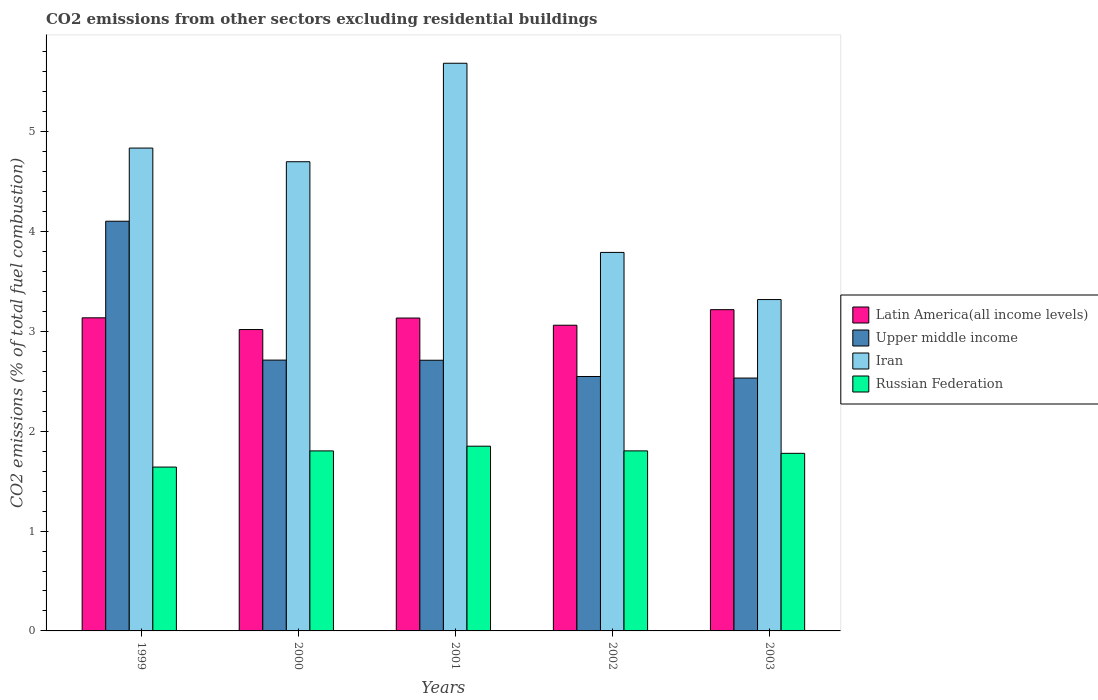How many different coloured bars are there?
Your answer should be compact. 4. Are the number of bars per tick equal to the number of legend labels?
Ensure brevity in your answer.  Yes. How many bars are there on the 5th tick from the left?
Ensure brevity in your answer.  4. What is the label of the 1st group of bars from the left?
Give a very brief answer. 1999. In how many cases, is the number of bars for a given year not equal to the number of legend labels?
Provide a short and direct response. 0. What is the total CO2 emitted in Russian Federation in 2001?
Offer a terse response. 1.85. Across all years, what is the maximum total CO2 emitted in Russian Federation?
Offer a terse response. 1.85. Across all years, what is the minimum total CO2 emitted in Iran?
Provide a short and direct response. 3.32. In which year was the total CO2 emitted in Iran maximum?
Offer a terse response. 2001. In which year was the total CO2 emitted in Iran minimum?
Give a very brief answer. 2003. What is the total total CO2 emitted in Upper middle income in the graph?
Provide a succinct answer. 14.61. What is the difference between the total CO2 emitted in Upper middle income in 2001 and that in 2002?
Ensure brevity in your answer.  0.16. What is the difference between the total CO2 emitted in Upper middle income in 2000 and the total CO2 emitted in Iran in 2001?
Provide a succinct answer. -2.97. What is the average total CO2 emitted in Iran per year?
Your answer should be very brief. 4.47. In the year 2002, what is the difference between the total CO2 emitted in Russian Federation and total CO2 emitted in Latin America(all income levels)?
Ensure brevity in your answer.  -1.26. What is the ratio of the total CO2 emitted in Upper middle income in 2000 to that in 2003?
Offer a very short reply. 1.07. Is the total CO2 emitted in Iran in 1999 less than that in 2003?
Your answer should be very brief. No. What is the difference between the highest and the second highest total CO2 emitted in Latin America(all income levels)?
Keep it short and to the point. 0.08. What is the difference between the highest and the lowest total CO2 emitted in Iran?
Give a very brief answer. 2.37. Is the sum of the total CO2 emitted in Latin America(all income levels) in 2001 and 2002 greater than the maximum total CO2 emitted in Upper middle income across all years?
Offer a very short reply. Yes. Is it the case that in every year, the sum of the total CO2 emitted in Iran and total CO2 emitted in Latin America(all income levels) is greater than the sum of total CO2 emitted in Russian Federation and total CO2 emitted in Upper middle income?
Give a very brief answer. Yes. What does the 1st bar from the left in 2002 represents?
Ensure brevity in your answer.  Latin America(all income levels). What does the 3rd bar from the right in 1999 represents?
Your answer should be compact. Upper middle income. What is the difference between two consecutive major ticks on the Y-axis?
Give a very brief answer. 1. Are the values on the major ticks of Y-axis written in scientific E-notation?
Ensure brevity in your answer.  No. What is the title of the graph?
Provide a short and direct response. CO2 emissions from other sectors excluding residential buildings. Does "Egypt, Arab Rep." appear as one of the legend labels in the graph?
Your response must be concise. No. What is the label or title of the Y-axis?
Provide a short and direct response. CO2 emissions (% of total fuel combustion). What is the CO2 emissions (% of total fuel combustion) of Latin America(all income levels) in 1999?
Your answer should be compact. 3.14. What is the CO2 emissions (% of total fuel combustion) in Upper middle income in 1999?
Your answer should be very brief. 4.1. What is the CO2 emissions (% of total fuel combustion) in Iran in 1999?
Your response must be concise. 4.84. What is the CO2 emissions (% of total fuel combustion) of Russian Federation in 1999?
Give a very brief answer. 1.64. What is the CO2 emissions (% of total fuel combustion) in Latin America(all income levels) in 2000?
Your response must be concise. 3.02. What is the CO2 emissions (% of total fuel combustion) of Upper middle income in 2000?
Your answer should be very brief. 2.71. What is the CO2 emissions (% of total fuel combustion) of Iran in 2000?
Offer a terse response. 4.7. What is the CO2 emissions (% of total fuel combustion) in Russian Federation in 2000?
Provide a short and direct response. 1.8. What is the CO2 emissions (% of total fuel combustion) of Latin America(all income levels) in 2001?
Give a very brief answer. 3.13. What is the CO2 emissions (% of total fuel combustion) of Upper middle income in 2001?
Make the answer very short. 2.71. What is the CO2 emissions (% of total fuel combustion) of Iran in 2001?
Provide a succinct answer. 5.69. What is the CO2 emissions (% of total fuel combustion) in Russian Federation in 2001?
Your response must be concise. 1.85. What is the CO2 emissions (% of total fuel combustion) in Latin America(all income levels) in 2002?
Your answer should be very brief. 3.06. What is the CO2 emissions (% of total fuel combustion) in Upper middle income in 2002?
Provide a succinct answer. 2.55. What is the CO2 emissions (% of total fuel combustion) in Iran in 2002?
Offer a terse response. 3.79. What is the CO2 emissions (% of total fuel combustion) of Russian Federation in 2002?
Offer a very short reply. 1.8. What is the CO2 emissions (% of total fuel combustion) of Latin America(all income levels) in 2003?
Make the answer very short. 3.22. What is the CO2 emissions (% of total fuel combustion) in Upper middle income in 2003?
Give a very brief answer. 2.53. What is the CO2 emissions (% of total fuel combustion) of Iran in 2003?
Give a very brief answer. 3.32. What is the CO2 emissions (% of total fuel combustion) in Russian Federation in 2003?
Your response must be concise. 1.78. Across all years, what is the maximum CO2 emissions (% of total fuel combustion) of Latin America(all income levels)?
Ensure brevity in your answer.  3.22. Across all years, what is the maximum CO2 emissions (% of total fuel combustion) of Upper middle income?
Provide a short and direct response. 4.1. Across all years, what is the maximum CO2 emissions (% of total fuel combustion) of Iran?
Your answer should be compact. 5.69. Across all years, what is the maximum CO2 emissions (% of total fuel combustion) of Russian Federation?
Provide a succinct answer. 1.85. Across all years, what is the minimum CO2 emissions (% of total fuel combustion) of Latin America(all income levels)?
Offer a very short reply. 3.02. Across all years, what is the minimum CO2 emissions (% of total fuel combustion) in Upper middle income?
Offer a terse response. 2.53. Across all years, what is the minimum CO2 emissions (% of total fuel combustion) in Iran?
Provide a succinct answer. 3.32. Across all years, what is the minimum CO2 emissions (% of total fuel combustion) in Russian Federation?
Offer a very short reply. 1.64. What is the total CO2 emissions (% of total fuel combustion) in Latin America(all income levels) in the graph?
Provide a short and direct response. 15.57. What is the total CO2 emissions (% of total fuel combustion) in Upper middle income in the graph?
Provide a succinct answer. 14.61. What is the total CO2 emissions (% of total fuel combustion) in Iran in the graph?
Give a very brief answer. 22.33. What is the total CO2 emissions (% of total fuel combustion) in Russian Federation in the graph?
Provide a succinct answer. 8.88. What is the difference between the CO2 emissions (% of total fuel combustion) of Latin America(all income levels) in 1999 and that in 2000?
Your response must be concise. 0.12. What is the difference between the CO2 emissions (% of total fuel combustion) in Upper middle income in 1999 and that in 2000?
Make the answer very short. 1.39. What is the difference between the CO2 emissions (% of total fuel combustion) in Iran in 1999 and that in 2000?
Give a very brief answer. 0.14. What is the difference between the CO2 emissions (% of total fuel combustion) of Russian Federation in 1999 and that in 2000?
Your answer should be compact. -0.16. What is the difference between the CO2 emissions (% of total fuel combustion) of Latin America(all income levels) in 1999 and that in 2001?
Offer a very short reply. 0. What is the difference between the CO2 emissions (% of total fuel combustion) of Upper middle income in 1999 and that in 2001?
Your response must be concise. 1.39. What is the difference between the CO2 emissions (% of total fuel combustion) of Iran in 1999 and that in 2001?
Ensure brevity in your answer.  -0.85. What is the difference between the CO2 emissions (% of total fuel combustion) of Russian Federation in 1999 and that in 2001?
Give a very brief answer. -0.21. What is the difference between the CO2 emissions (% of total fuel combustion) in Latin America(all income levels) in 1999 and that in 2002?
Provide a succinct answer. 0.07. What is the difference between the CO2 emissions (% of total fuel combustion) of Upper middle income in 1999 and that in 2002?
Keep it short and to the point. 1.56. What is the difference between the CO2 emissions (% of total fuel combustion) of Iran in 1999 and that in 2002?
Make the answer very short. 1.05. What is the difference between the CO2 emissions (% of total fuel combustion) in Russian Federation in 1999 and that in 2002?
Provide a short and direct response. -0.16. What is the difference between the CO2 emissions (% of total fuel combustion) in Latin America(all income levels) in 1999 and that in 2003?
Make the answer very short. -0.08. What is the difference between the CO2 emissions (% of total fuel combustion) in Upper middle income in 1999 and that in 2003?
Offer a terse response. 1.57. What is the difference between the CO2 emissions (% of total fuel combustion) in Iran in 1999 and that in 2003?
Offer a very short reply. 1.52. What is the difference between the CO2 emissions (% of total fuel combustion) in Russian Federation in 1999 and that in 2003?
Make the answer very short. -0.14. What is the difference between the CO2 emissions (% of total fuel combustion) in Latin America(all income levels) in 2000 and that in 2001?
Your answer should be very brief. -0.12. What is the difference between the CO2 emissions (% of total fuel combustion) in Upper middle income in 2000 and that in 2001?
Keep it short and to the point. 0. What is the difference between the CO2 emissions (% of total fuel combustion) in Iran in 2000 and that in 2001?
Keep it short and to the point. -0.99. What is the difference between the CO2 emissions (% of total fuel combustion) of Russian Federation in 2000 and that in 2001?
Offer a very short reply. -0.05. What is the difference between the CO2 emissions (% of total fuel combustion) of Latin America(all income levels) in 2000 and that in 2002?
Give a very brief answer. -0.04. What is the difference between the CO2 emissions (% of total fuel combustion) in Upper middle income in 2000 and that in 2002?
Your response must be concise. 0.16. What is the difference between the CO2 emissions (% of total fuel combustion) in Iran in 2000 and that in 2002?
Keep it short and to the point. 0.91. What is the difference between the CO2 emissions (% of total fuel combustion) of Russian Federation in 2000 and that in 2002?
Make the answer very short. -0. What is the difference between the CO2 emissions (% of total fuel combustion) in Latin America(all income levels) in 2000 and that in 2003?
Offer a terse response. -0.2. What is the difference between the CO2 emissions (% of total fuel combustion) in Upper middle income in 2000 and that in 2003?
Make the answer very short. 0.18. What is the difference between the CO2 emissions (% of total fuel combustion) of Iran in 2000 and that in 2003?
Offer a very short reply. 1.38. What is the difference between the CO2 emissions (% of total fuel combustion) in Russian Federation in 2000 and that in 2003?
Offer a terse response. 0.02. What is the difference between the CO2 emissions (% of total fuel combustion) of Latin America(all income levels) in 2001 and that in 2002?
Give a very brief answer. 0.07. What is the difference between the CO2 emissions (% of total fuel combustion) in Upper middle income in 2001 and that in 2002?
Your answer should be compact. 0.16. What is the difference between the CO2 emissions (% of total fuel combustion) in Iran in 2001 and that in 2002?
Give a very brief answer. 1.89. What is the difference between the CO2 emissions (% of total fuel combustion) of Russian Federation in 2001 and that in 2002?
Your response must be concise. 0.05. What is the difference between the CO2 emissions (% of total fuel combustion) of Latin America(all income levels) in 2001 and that in 2003?
Your response must be concise. -0.08. What is the difference between the CO2 emissions (% of total fuel combustion) in Upper middle income in 2001 and that in 2003?
Give a very brief answer. 0.18. What is the difference between the CO2 emissions (% of total fuel combustion) in Iran in 2001 and that in 2003?
Provide a succinct answer. 2.37. What is the difference between the CO2 emissions (% of total fuel combustion) in Russian Federation in 2001 and that in 2003?
Make the answer very short. 0.07. What is the difference between the CO2 emissions (% of total fuel combustion) of Latin America(all income levels) in 2002 and that in 2003?
Offer a very short reply. -0.16. What is the difference between the CO2 emissions (% of total fuel combustion) in Upper middle income in 2002 and that in 2003?
Offer a terse response. 0.02. What is the difference between the CO2 emissions (% of total fuel combustion) in Iran in 2002 and that in 2003?
Your answer should be compact. 0.47. What is the difference between the CO2 emissions (% of total fuel combustion) in Russian Federation in 2002 and that in 2003?
Offer a very short reply. 0.02. What is the difference between the CO2 emissions (% of total fuel combustion) in Latin America(all income levels) in 1999 and the CO2 emissions (% of total fuel combustion) in Upper middle income in 2000?
Offer a very short reply. 0.42. What is the difference between the CO2 emissions (% of total fuel combustion) of Latin America(all income levels) in 1999 and the CO2 emissions (% of total fuel combustion) of Iran in 2000?
Offer a terse response. -1.56. What is the difference between the CO2 emissions (% of total fuel combustion) of Latin America(all income levels) in 1999 and the CO2 emissions (% of total fuel combustion) of Russian Federation in 2000?
Offer a very short reply. 1.33. What is the difference between the CO2 emissions (% of total fuel combustion) of Upper middle income in 1999 and the CO2 emissions (% of total fuel combustion) of Iran in 2000?
Give a very brief answer. -0.6. What is the difference between the CO2 emissions (% of total fuel combustion) of Upper middle income in 1999 and the CO2 emissions (% of total fuel combustion) of Russian Federation in 2000?
Ensure brevity in your answer.  2.3. What is the difference between the CO2 emissions (% of total fuel combustion) in Iran in 1999 and the CO2 emissions (% of total fuel combustion) in Russian Federation in 2000?
Ensure brevity in your answer.  3.03. What is the difference between the CO2 emissions (% of total fuel combustion) of Latin America(all income levels) in 1999 and the CO2 emissions (% of total fuel combustion) of Upper middle income in 2001?
Provide a short and direct response. 0.42. What is the difference between the CO2 emissions (% of total fuel combustion) of Latin America(all income levels) in 1999 and the CO2 emissions (% of total fuel combustion) of Iran in 2001?
Make the answer very short. -2.55. What is the difference between the CO2 emissions (% of total fuel combustion) of Latin America(all income levels) in 1999 and the CO2 emissions (% of total fuel combustion) of Russian Federation in 2001?
Your answer should be compact. 1.29. What is the difference between the CO2 emissions (% of total fuel combustion) in Upper middle income in 1999 and the CO2 emissions (% of total fuel combustion) in Iran in 2001?
Ensure brevity in your answer.  -1.58. What is the difference between the CO2 emissions (% of total fuel combustion) of Upper middle income in 1999 and the CO2 emissions (% of total fuel combustion) of Russian Federation in 2001?
Ensure brevity in your answer.  2.25. What is the difference between the CO2 emissions (% of total fuel combustion) in Iran in 1999 and the CO2 emissions (% of total fuel combustion) in Russian Federation in 2001?
Ensure brevity in your answer.  2.99. What is the difference between the CO2 emissions (% of total fuel combustion) in Latin America(all income levels) in 1999 and the CO2 emissions (% of total fuel combustion) in Upper middle income in 2002?
Ensure brevity in your answer.  0.59. What is the difference between the CO2 emissions (% of total fuel combustion) in Latin America(all income levels) in 1999 and the CO2 emissions (% of total fuel combustion) in Iran in 2002?
Your answer should be very brief. -0.66. What is the difference between the CO2 emissions (% of total fuel combustion) of Latin America(all income levels) in 1999 and the CO2 emissions (% of total fuel combustion) of Russian Federation in 2002?
Ensure brevity in your answer.  1.33. What is the difference between the CO2 emissions (% of total fuel combustion) of Upper middle income in 1999 and the CO2 emissions (% of total fuel combustion) of Iran in 2002?
Provide a succinct answer. 0.31. What is the difference between the CO2 emissions (% of total fuel combustion) of Upper middle income in 1999 and the CO2 emissions (% of total fuel combustion) of Russian Federation in 2002?
Offer a very short reply. 2.3. What is the difference between the CO2 emissions (% of total fuel combustion) in Iran in 1999 and the CO2 emissions (% of total fuel combustion) in Russian Federation in 2002?
Give a very brief answer. 3.03. What is the difference between the CO2 emissions (% of total fuel combustion) in Latin America(all income levels) in 1999 and the CO2 emissions (% of total fuel combustion) in Upper middle income in 2003?
Your response must be concise. 0.6. What is the difference between the CO2 emissions (% of total fuel combustion) in Latin America(all income levels) in 1999 and the CO2 emissions (% of total fuel combustion) in Iran in 2003?
Offer a terse response. -0.18. What is the difference between the CO2 emissions (% of total fuel combustion) in Latin America(all income levels) in 1999 and the CO2 emissions (% of total fuel combustion) in Russian Federation in 2003?
Give a very brief answer. 1.36. What is the difference between the CO2 emissions (% of total fuel combustion) in Upper middle income in 1999 and the CO2 emissions (% of total fuel combustion) in Iran in 2003?
Ensure brevity in your answer.  0.78. What is the difference between the CO2 emissions (% of total fuel combustion) of Upper middle income in 1999 and the CO2 emissions (% of total fuel combustion) of Russian Federation in 2003?
Make the answer very short. 2.33. What is the difference between the CO2 emissions (% of total fuel combustion) of Iran in 1999 and the CO2 emissions (% of total fuel combustion) of Russian Federation in 2003?
Make the answer very short. 3.06. What is the difference between the CO2 emissions (% of total fuel combustion) of Latin America(all income levels) in 2000 and the CO2 emissions (% of total fuel combustion) of Upper middle income in 2001?
Offer a terse response. 0.31. What is the difference between the CO2 emissions (% of total fuel combustion) of Latin America(all income levels) in 2000 and the CO2 emissions (% of total fuel combustion) of Iran in 2001?
Provide a short and direct response. -2.67. What is the difference between the CO2 emissions (% of total fuel combustion) of Latin America(all income levels) in 2000 and the CO2 emissions (% of total fuel combustion) of Russian Federation in 2001?
Provide a short and direct response. 1.17. What is the difference between the CO2 emissions (% of total fuel combustion) of Upper middle income in 2000 and the CO2 emissions (% of total fuel combustion) of Iran in 2001?
Ensure brevity in your answer.  -2.97. What is the difference between the CO2 emissions (% of total fuel combustion) of Upper middle income in 2000 and the CO2 emissions (% of total fuel combustion) of Russian Federation in 2001?
Your answer should be very brief. 0.86. What is the difference between the CO2 emissions (% of total fuel combustion) of Iran in 2000 and the CO2 emissions (% of total fuel combustion) of Russian Federation in 2001?
Your response must be concise. 2.85. What is the difference between the CO2 emissions (% of total fuel combustion) in Latin America(all income levels) in 2000 and the CO2 emissions (% of total fuel combustion) in Upper middle income in 2002?
Your answer should be compact. 0.47. What is the difference between the CO2 emissions (% of total fuel combustion) of Latin America(all income levels) in 2000 and the CO2 emissions (% of total fuel combustion) of Iran in 2002?
Your answer should be compact. -0.77. What is the difference between the CO2 emissions (% of total fuel combustion) in Latin America(all income levels) in 2000 and the CO2 emissions (% of total fuel combustion) in Russian Federation in 2002?
Provide a short and direct response. 1.22. What is the difference between the CO2 emissions (% of total fuel combustion) of Upper middle income in 2000 and the CO2 emissions (% of total fuel combustion) of Iran in 2002?
Your answer should be very brief. -1.08. What is the difference between the CO2 emissions (% of total fuel combustion) in Upper middle income in 2000 and the CO2 emissions (% of total fuel combustion) in Russian Federation in 2002?
Provide a short and direct response. 0.91. What is the difference between the CO2 emissions (% of total fuel combustion) in Iran in 2000 and the CO2 emissions (% of total fuel combustion) in Russian Federation in 2002?
Provide a succinct answer. 2.9. What is the difference between the CO2 emissions (% of total fuel combustion) of Latin America(all income levels) in 2000 and the CO2 emissions (% of total fuel combustion) of Upper middle income in 2003?
Make the answer very short. 0.49. What is the difference between the CO2 emissions (% of total fuel combustion) of Latin America(all income levels) in 2000 and the CO2 emissions (% of total fuel combustion) of Iran in 2003?
Offer a terse response. -0.3. What is the difference between the CO2 emissions (% of total fuel combustion) of Latin America(all income levels) in 2000 and the CO2 emissions (% of total fuel combustion) of Russian Federation in 2003?
Give a very brief answer. 1.24. What is the difference between the CO2 emissions (% of total fuel combustion) in Upper middle income in 2000 and the CO2 emissions (% of total fuel combustion) in Iran in 2003?
Give a very brief answer. -0.61. What is the difference between the CO2 emissions (% of total fuel combustion) in Upper middle income in 2000 and the CO2 emissions (% of total fuel combustion) in Russian Federation in 2003?
Give a very brief answer. 0.93. What is the difference between the CO2 emissions (% of total fuel combustion) in Iran in 2000 and the CO2 emissions (% of total fuel combustion) in Russian Federation in 2003?
Offer a very short reply. 2.92. What is the difference between the CO2 emissions (% of total fuel combustion) of Latin America(all income levels) in 2001 and the CO2 emissions (% of total fuel combustion) of Upper middle income in 2002?
Your answer should be compact. 0.59. What is the difference between the CO2 emissions (% of total fuel combustion) of Latin America(all income levels) in 2001 and the CO2 emissions (% of total fuel combustion) of Iran in 2002?
Give a very brief answer. -0.66. What is the difference between the CO2 emissions (% of total fuel combustion) of Latin America(all income levels) in 2001 and the CO2 emissions (% of total fuel combustion) of Russian Federation in 2002?
Keep it short and to the point. 1.33. What is the difference between the CO2 emissions (% of total fuel combustion) in Upper middle income in 2001 and the CO2 emissions (% of total fuel combustion) in Iran in 2002?
Offer a terse response. -1.08. What is the difference between the CO2 emissions (% of total fuel combustion) in Upper middle income in 2001 and the CO2 emissions (% of total fuel combustion) in Russian Federation in 2002?
Your answer should be compact. 0.91. What is the difference between the CO2 emissions (% of total fuel combustion) of Iran in 2001 and the CO2 emissions (% of total fuel combustion) of Russian Federation in 2002?
Provide a short and direct response. 3.88. What is the difference between the CO2 emissions (% of total fuel combustion) in Latin America(all income levels) in 2001 and the CO2 emissions (% of total fuel combustion) in Upper middle income in 2003?
Offer a terse response. 0.6. What is the difference between the CO2 emissions (% of total fuel combustion) in Latin America(all income levels) in 2001 and the CO2 emissions (% of total fuel combustion) in Iran in 2003?
Keep it short and to the point. -0.18. What is the difference between the CO2 emissions (% of total fuel combustion) in Latin America(all income levels) in 2001 and the CO2 emissions (% of total fuel combustion) in Russian Federation in 2003?
Offer a very short reply. 1.36. What is the difference between the CO2 emissions (% of total fuel combustion) in Upper middle income in 2001 and the CO2 emissions (% of total fuel combustion) in Iran in 2003?
Offer a terse response. -0.61. What is the difference between the CO2 emissions (% of total fuel combustion) of Upper middle income in 2001 and the CO2 emissions (% of total fuel combustion) of Russian Federation in 2003?
Provide a succinct answer. 0.93. What is the difference between the CO2 emissions (% of total fuel combustion) of Iran in 2001 and the CO2 emissions (% of total fuel combustion) of Russian Federation in 2003?
Keep it short and to the point. 3.91. What is the difference between the CO2 emissions (% of total fuel combustion) in Latin America(all income levels) in 2002 and the CO2 emissions (% of total fuel combustion) in Upper middle income in 2003?
Your answer should be compact. 0.53. What is the difference between the CO2 emissions (% of total fuel combustion) in Latin America(all income levels) in 2002 and the CO2 emissions (% of total fuel combustion) in Iran in 2003?
Make the answer very short. -0.26. What is the difference between the CO2 emissions (% of total fuel combustion) of Latin America(all income levels) in 2002 and the CO2 emissions (% of total fuel combustion) of Russian Federation in 2003?
Your response must be concise. 1.28. What is the difference between the CO2 emissions (% of total fuel combustion) of Upper middle income in 2002 and the CO2 emissions (% of total fuel combustion) of Iran in 2003?
Make the answer very short. -0.77. What is the difference between the CO2 emissions (% of total fuel combustion) of Upper middle income in 2002 and the CO2 emissions (% of total fuel combustion) of Russian Federation in 2003?
Give a very brief answer. 0.77. What is the difference between the CO2 emissions (% of total fuel combustion) of Iran in 2002 and the CO2 emissions (% of total fuel combustion) of Russian Federation in 2003?
Make the answer very short. 2.01. What is the average CO2 emissions (% of total fuel combustion) in Latin America(all income levels) per year?
Your answer should be very brief. 3.11. What is the average CO2 emissions (% of total fuel combustion) of Upper middle income per year?
Your answer should be very brief. 2.92. What is the average CO2 emissions (% of total fuel combustion) in Iran per year?
Provide a succinct answer. 4.47. What is the average CO2 emissions (% of total fuel combustion) of Russian Federation per year?
Your response must be concise. 1.78. In the year 1999, what is the difference between the CO2 emissions (% of total fuel combustion) in Latin America(all income levels) and CO2 emissions (% of total fuel combustion) in Upper middle income?
Keep it short and to the point. -0.97. In the year 1999, what is the difference between the CO2 emissions (% of total fuel combustion) in Latin America(all income levels) and CO2 emissions (% of total fuel combustion) in Iran?
Give a very brief answer. -1.7. In the year 1999, what is the difference between the CO2 emissions (% of total fuel combustion) of Latin America(all income levels) and CO2 emissions (% of total fuel combustion) of Russian Federation?
Make the answer very short. 1.5. In the year 1999, what is the difference between the CO2 emissions (% of total fuel combustion) in Upper middle income and CO2 emissions (% of total fuel combustion) in Iran?
Your answer should be very brief. -0.73. In the year 1999, what is the difference between the CO2 emissions (% of total fuel combustion) in Upper middle income and CO2 emissions (% of total fuel combustion) in Russian Federation?
Make the answer very short. 2.46. In the year 1999, what is the difference between the CO2 emissions (% of total fuel combustion) in Iran and CO2 emissions (% of total fuel combustion) in Russian Federation?
Provide a succinct answer. 3.2. In the year 2000, what is the difference between the CO2 emissions (% of total fuel combustion) of Latin America(all income levels) and CO2 emissions (% of total fuel combustion) of Upper middle income?
Keep it short and to the point. 0.31. In the year 2000, what is the difference between the CO2 emissions (% of total fuel combustion) of Latin America(all income levels) and CO2 emissions (% of total fuel combustion) of Iran?
Your response must be concise. -1.68. In the year 2000, what is the difference between the CO2 emissions (% of total fuel combustion) in Latin America(all income levels) and CO2 emissions (% of total fuel combustion) in Russian Federation?
Keep it short and to the point. 1.22. In the year 2000, what is the difference between the CO2 emissions (% of total fuel combustion) in Upper middle income and CO2 emissions (% of total fuel combustion) in Iran?
Give a very brief answer. -1.99. In the year 2000, what is the difference between the CO2 emissions (% of total fuel combustion) in Upper middle income and CO2 emissions (% of total fuel combustion) in Russian Federation?
Give a very brief answer. 0.91. In the year 2000, what is the difference between the CO2 emissions (% of total fuel combustion) in Iran and CO2 emissions (% of total fuel combustion) in Russian Federation?
Keep it short and to the point. 2.9. In the year 2001, what is the difference between the CO2 emissions (% of total fuel combustion) of Latin America(all income levels) and CO2 emissions (% of total fuel combustion) of Upper middle income?
Offer a terse response. 0.42. In the year 2001, what is the difference between the CO2 emissions (% of total fuel combustion) in Latin America(all income levels) and CO2 emissions (% of total fuel combustion) in Iran?
Make the answer very short. -2.55. In the year 2001, what is the difference between the CO2 emissions (% of total fuel combustion) of Latin America(all income levels) and CO2 emissions (% of total fuel combustion) of Russian Federation?
Your answer should be compact. 1.28. In the year 2001, what is the difference between the CO2 emissions (% of total fuel combustion) in Upper middle income and CO2 emissions (% of total fuel combustion) in Iran?
Your answer should be very brief. -2.97. In the year 2001, what is the difference between the CO2 emissions (% of total fuel combustion) in Upper middle income and CO2 emissions (% of total fuel combustion) in Russian Federation?
Your response must be concise. 0.86. In the year 2001, what is the difference between the CO2 emissions (% of total fuel combustion) of Iran and CO2 emissions (% of total fuel combustion) of Russian Federation?
Keep it short and to the point. 3.84. In the year 2002, what is the difference between the CO2 emissions (% of total fuel combustion) in Latin America(all income levels) and CO2 emissions (% of total fuel combustion) in Upper middle income?
Your answer should be very brief. 0.51. In the year 2002, what is the difference between the CO2 emissions (% of total fuel combustion) in Latin America(all income levels) and CO2 emissions (% of total fuel combustion) in Iran?
Give a very brief answer. -0.73. In the year 2002, what is the difference between the CO2 emissions (% of total fuel combustion) of Latin America(all income levels) and CO2 emissions (% of total fuel combustion) of Russian Federation?
Ensure brevity in your answer.  1.26. In the year 2002, what is the difference between the CO2 emissions (% of total fuel combustion) in Upper middle income and CO2 emissions (% of total fuel combustion) in Iran?
Your answer should be compact. -1.24. In the year 2002, what is the difference between the CO2 emissions (% of total fuel combustion) in Upper middle income and CO2 emissions (% of total fuel combustion) in Russian Federation?
Provide a succinct answer. 0.75. In the year 2002, what is the difference between the CO2 emissions (% of total fuel combustion) in Iran and CO2 emissions (% of total fuel combustion) in Russian Federation?
Your response must be concise. 1.99. In the year 2003, what is the difference between the CO2 emissions (% of total fuel combustion) of Latin America(all income levels) and CO2 emissions (% of total fuel combustion) of Upper middle income?
Provide a succinct answer. 0.69. In the year 2003, what is the difference between the CO2 emissions (% of total fuel combustion) in Latin America(all income levels) and CO2 emissions (% of total fuel combustion) in Iran?
Your answer should be very brief. -0.1. In the year 2003, what is the difference between the CO2 emissions (% of total fuel combustion) in Latin America(all income levels) and CO2 emissions (% of total fuel combustion) in Russian Federation?
Ensure brevity in your answer.  1.44. In the year 2003, what is the difference between the CO2 emissions (% of total fuel combustion) in Upper middle income and CO2 emissions (% of total fuel combustion) in Iran?
Keep it short and to the point. -0.79. In the year 2003, what is the difference between the CO2 emissions (% of total fuel combustion) of Upper middle income and CO2 emissions (% of total fuel combustion) of Russian Federation?
Ensure brevity in your answer.  0.75. In the year 2003, what is the difference between the CO2 emissions (% of total fuel combustion) in Iran and CO2 emissions (% of total fuel combustion) in Russian Federation?
Your response must be concise. 1.54. What is the ratio of the CO2 emissions (% of total fuel combustion) in Latin America(all income levels) in 1999 to that in 2000?
Give a very brief answer. 1.04. What is the ratio of the CO2 emissions (% of total fuel combustion) in Upper middle income in 1999 to that in 2000?
Make the answer very short. 1.51. What is the ratio of the CO2 emissions (% of total fuel combustion) of Iran in 1999 to that in 2000?
Ensure brevity in your answer.  1.03. What is the ratio of the CO2 emissions (% of total fuel combustion) of Russian Federation in 1999 to that in 2000?
Your answer should be compact. 0.91. What is the ratio of the CO2 emissions (% of total fuel combustion) in Latin America(all income levels) in 1999 to that in 2001?
Your response must be concise. 1. What is the ratio of the CO2 emissions (% of total fuel combustion) of Upper middle income in 1999 to that in 2001?
Your response must be concise. 1.51. What is the ratio of the CO2 emissions (% of total fuel combustion) of Iran in 1999 to that in 2001?
Give a very brief answer. 0.85. What is the ratio of the CO2 emissions (% of total fuel combustion) in Russian Federation in 1999 to that in 2001?
Keep it short and to the point. 0.89. What is the ratio of the CO2 emissions (% of total fuel combustion) of Latin America(all income levels) in 1999 to that in 2002?
Make the answer very short. 1.02. What is the ratio of the CO2 emissions (% of total fuel combustion) in Upper middle income in 1999 to that in 2002?
Give a very brief answer. 1.61. What is the ratio of the CO2 emissions (% of total fuel combustion) of Iran in 1999 to that in 2002?
Provide a short and direct response. 1.28. What is the ratio of the CO2 emissions (% of total fuel combustion) of Russian Federation in 1999 to that in 2002?
Make the answer very short. 0.91. What is the ratio of the CO2 emissions (% of total fuel combustion) in Latin America(all income levels) in 1999 to that in 2003?
Offer a terse response. 0.97. What is the ratio of the CO2 emissions (% of total fuel combustion) of Upper middle income in 1999 to that in 2003?
Your answer should be very brief. 1.62. What is the ratio of the CO2 emissions (% of total fuel combustion) in Iran in 1999 to that in 2003?
Provide a succinct answer. 1.46. What is the ratio of the CO2 emissions (% of total fuel combustion) in Russian Federation in 1999 to that in 2003?
Offer a terse response. 0.92. What is the ratio of the CO2 emissions (% of total fuel combustion) in Latin America(all income levels) in 2000 to that in 2001?
Offer a very short reply. 0.96. What is the ratio of the CO2 emissions (% of total fuel combustion) of Iran in 2000 to that in 2001?
Your answer should be compact. 0.83. What is the ratio of the CO2 emissions (% of total fuel combustion) in Russian Federation in 2000 to that in 2001?
Provide a succinct answer. 0.97. What is the ratio of the CO2 emissions (% of total fuel combustion) of Latin America(all income levels) in 2000 to that in 2002?
Your answer should be compact. 0.99. What is the ratio of the CO2 emissions (% of total fuel combustion) in Upper middle income in 2000 to that in 2002?
Your response must be concise. 1.06. What is the ratio of the CO2 emissions (% of total fuel combustion) in Iran in 2000 to that in 2002?
Your response must be concise. 1.24. What is the ratio of the CO2 emissions (% of total fuel combustion) of Latin America(all income levels) in 2000 to that in 2003?
Your response must be concise. 0.94. What is the ratio of the CO2 emissions (% of total fuel combustion) in Upper middle income in 2000 to that in 2003?
Offer a terse response. 1.07. What is the ratio of the CO2 emissions (% of total fuel combustion) in Iran in 2000 to that in 2003?
Provide a short and direct response. 1.42. What is the ratio of the CO2 emissions (% of total fuel combustion) of Russian Federation in 2000 to that in 2003?
Make the answer very short. 1.01. What is the ratio of the CO2 emissions (% of total fuel combustion) in Latin America(all income levels) in 2001 to that in 2002?
Give a very brief answer. 1.02. What is the ratio of the CO2 emissions (% of total fuel combustion) of Upper middle income in 2001 to that in 2002?
Make the answer very short. 1.06. What is the ratio of the CO2 emissions (% of total fuel combustion) in Iran in 2001 to that in 2002?
Your answer should be compact. 1.5. What is the ratio of the CO2 emissions (% of total fuel combustion) of Russian Federation in 2001 to that in 2002?
Your answer should be very brief. 1.03. What is the ratio of the CO2 emissions (% of total fuel combustion) of Upper middle income in 2001 to that in 2003?
Offer a very short reply. 1.07. What is the ratio of the CO2 emissions (% of total fuel combustion) of Iran in 2001 to that in 2003?
Your answer should be compact. 1.71. What is the ratio of the CO2 emissions (% of total fuel combustion) in Russian Federation in 2001 to that in 2003?
Your answer should be compact. 1.04. What is the ratio of the CO2 emissions (% of total fuel combustion) in Latin America(all income levels) in 2002 to that in 2003?
Provide a succinct answer. 0.95. What is the ratio of the CO2 emissions (% of total fuel combustion) in Upper middle income in 2002 to that in 2003?
Offer a terse response. 1.01. What is the ratio of the CO2 emissions (% of total fuel combustion) of Iran in 2002 to that in 2003?
Your answer should be very brief. 1.14. What is the ratio of the CO2 emissions (% of total fuel combustion) in Russian Federation in 2002 to that in 2003?
Make the answer very short. 1.01. What is the difference between the highest and the second highest CO2 emissions (% of total fuel combustion) of Latin America(all income levels)?
Your answer should be very brief. 0.08. What is the difference between the highest and the second highest CO2 emissions (% of total fuel combustion) of Upper middle income?
Ensure brevity in your answer.  1.39. What is the difference between the highest and the second highest CO2 emissions (% of total fuel combustion) of Iran?
Your answer should be compact. 0.85. What is the difference between the highest and the second highest CO2 emissions (% of total fuel combustion) in Russian Federation?
Offer a very short reply. 0.05. What is the difference between the highest and the lowest CO2 emissions (% of total fuel combustion) of Latin America(all income levels)?
Provide a short and direct response. 0.2. What is the difference between the highest and the lowest CO2 emissions (% of total fuel combustion) of Upper middle income?
Your response must be concise. 1.57. What is the difference between the highest and the lowest CO2 emissions (% of total fuel combustion) in Iran?
Your response must be concise. 2.37. What is the difference between the highest and the lowest CO2 emissions (% of total fuel combustion) of Russian Federation?
Your response must be concise. 0.21. 